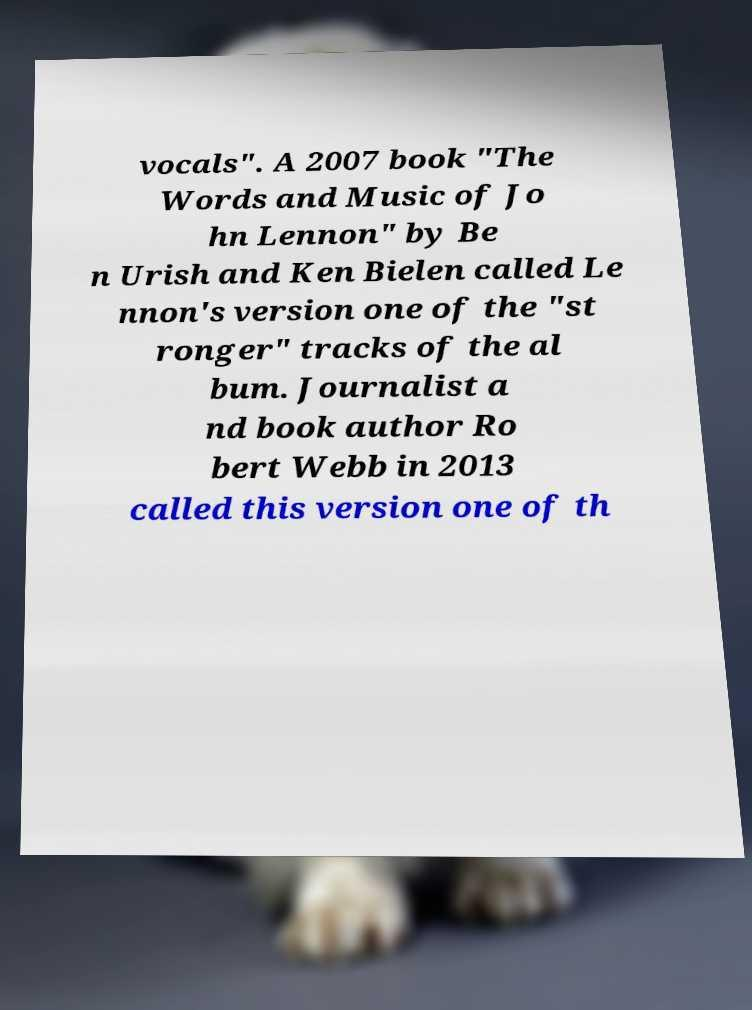Could you assist in decoding the text presented in this image and type it out clearly? vocals". A 2007 book "The Words and Music of Jo hn Lennon" by Be n Urish and Ken Bielen called Le nnon's version one of the "st ronger" tracks of the al bum. Journalist a nd book author Ro bert Webb in 2013 called this version one of th 